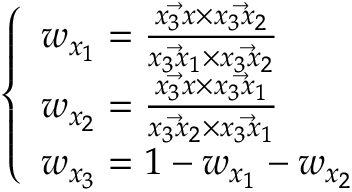<formula> <loc_0><loc_0><loc_500><loc_500>\left \{ \begin{array} { l l } { w _ { x _ { 1 } } = \frac { \ V e c { x _ { 3 } x } \times \ V e c { x _ { 3 } x _ { 2 } } } { \ V e c { x _ { 3 } x _ { 1 } } \times \ V e c { x _ { 3 } x _ { 2 } } } } \\ { w _ { x _ { 2 } } = \frac { \ V e c { x _ { 3 } x } \times \ V e c { x _ { 3 } x _ { 1 } } } { \ V e c { x _ { 3 } x _ { 2 } } \times \ V e c { x _ { 3 } x _ { 1 } } } } \\ { w _ { x _ { 3 } } = 1 - w _ { x _ { 1 } } - w _ { x _ { 2 } } } \end{array}</formula> 